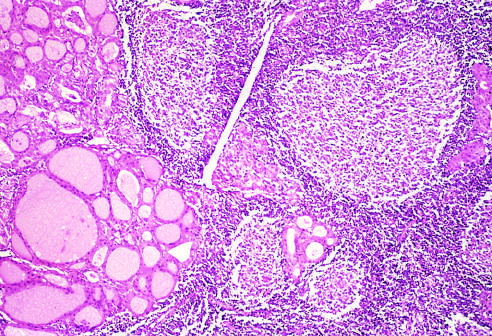does the transmural light area in the posterolateral left ventricle contain a dense lymphocytic infiltrate with germinal centers?
Answer the question using a single word or phrase. No 